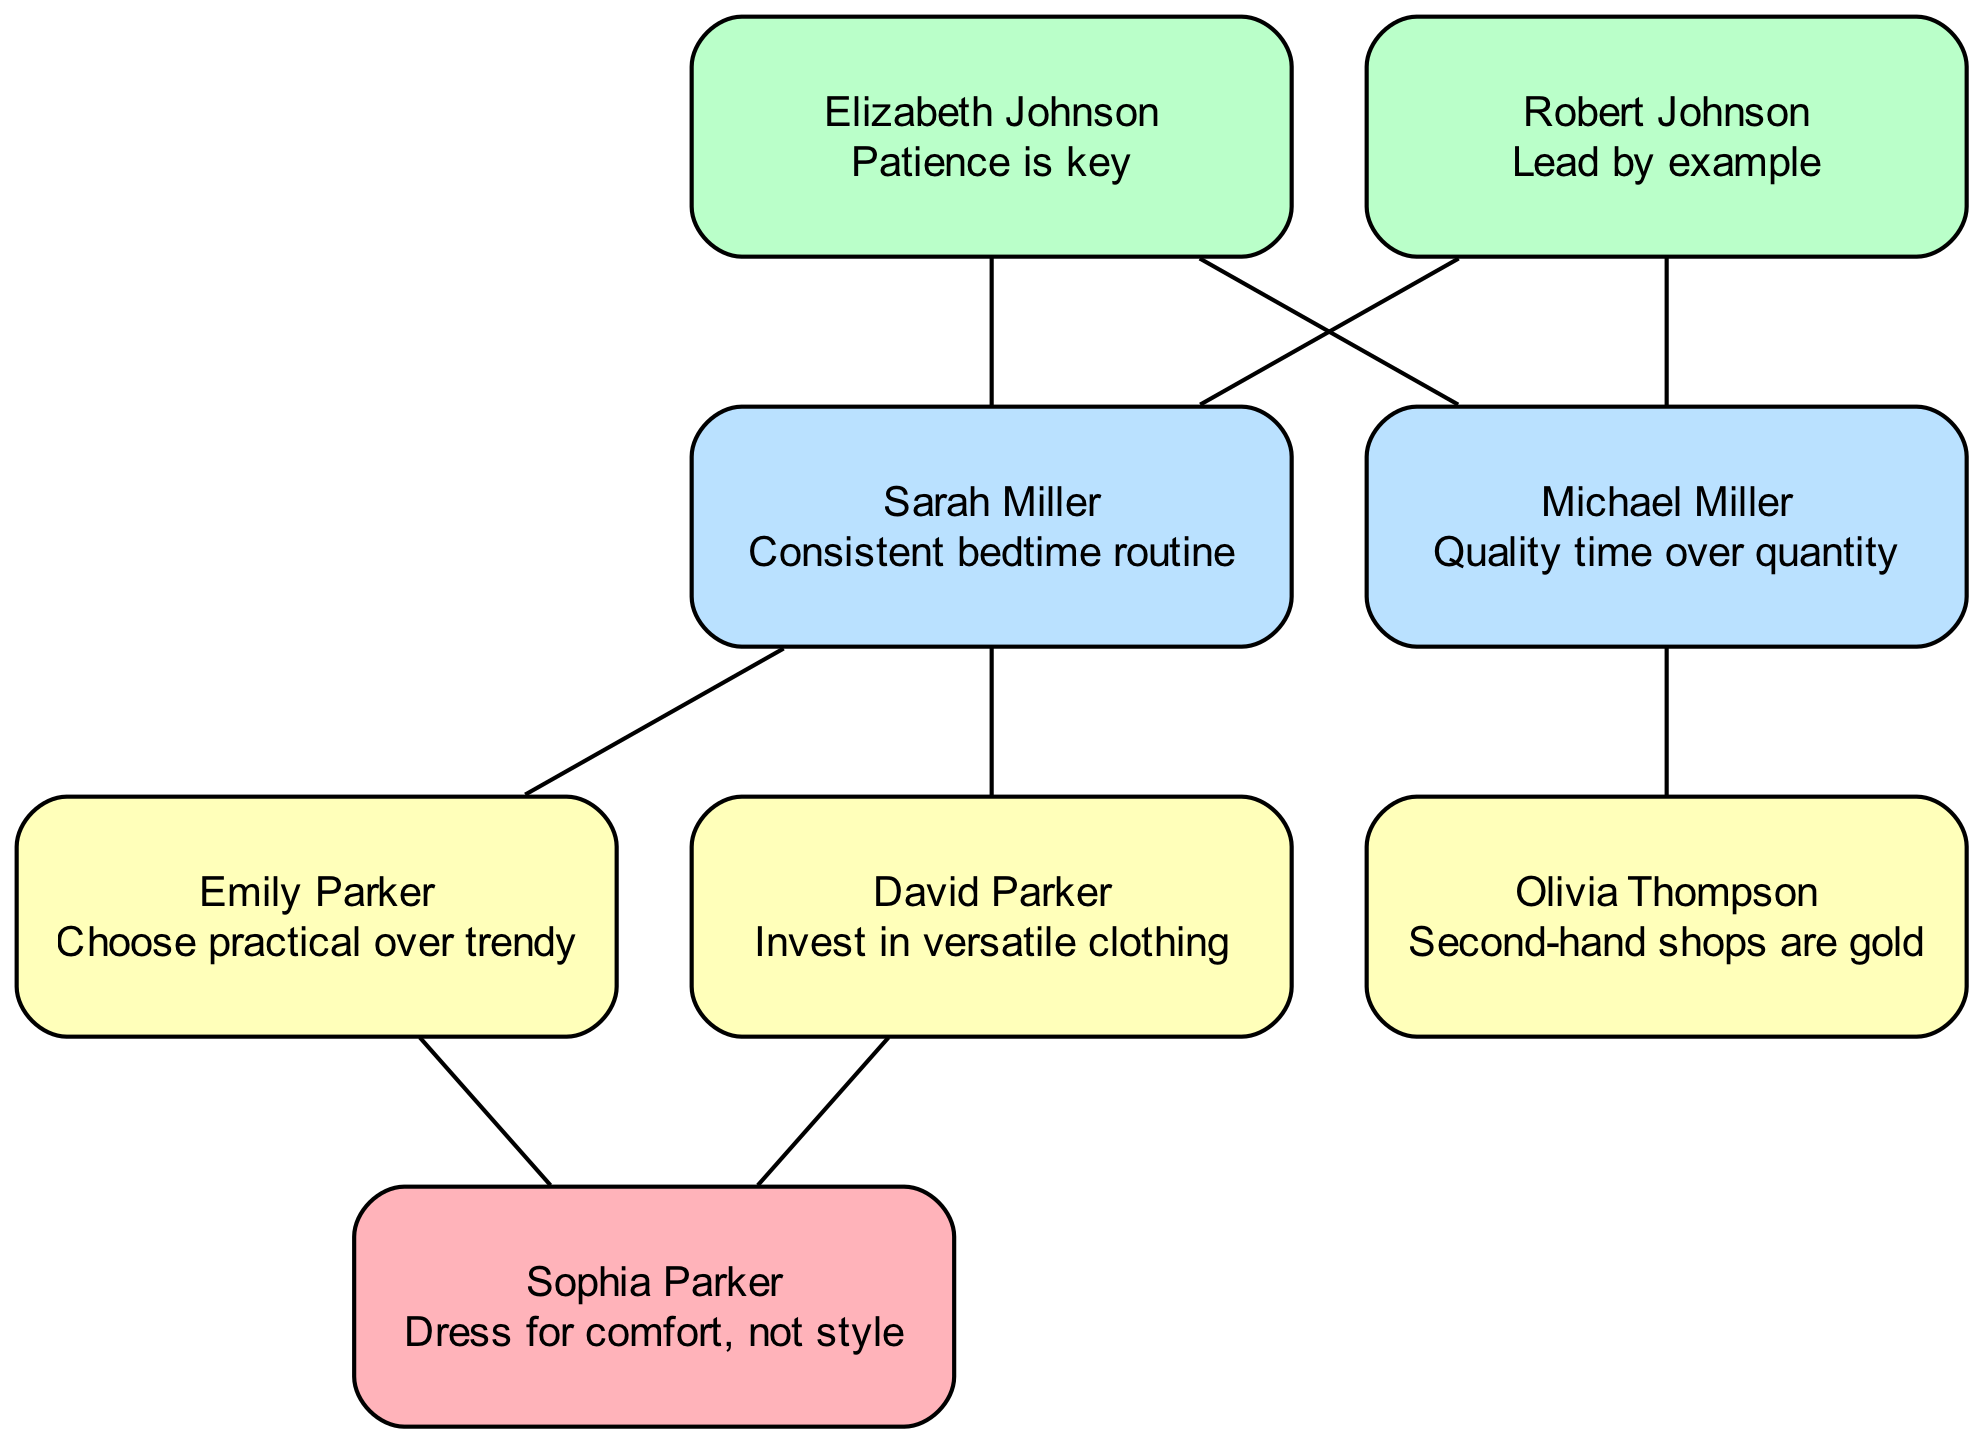What is Elizabeth Johnson's parenting advice? The diagram shows that Elizabeth Johnson's advice is presented directly in her node, with the text "Patience is key" clearly listed.
Answer: Patience is key How many generations are represented in the family tree? By counting the distinct generations in the provided data, we see that the first generation contains Elizabeth and Robert, the second contains Sarah and Michael, the third contains Emily, David, and Olivia, and the fourth has Sophia. This makes for a total of four generations.
Answer: 4 Who is the parent of Emily Parker? The tree indicates that Emily is connected to Sarah Miller, who is listed as her parent. By following the edges in the diagram, we can see this direct relationship.
Answer: Sarah Miller What is the advice given by Michael Miller? The advice specified under Michael Miller's node in the diagram is "Quality time over quantity," which is clearly stated.
Answer: Quality time over quantity Which family member advises to invest in versatile clothing? Looking at the information in the diagram, David Parker's node clearly states that his advice is "Invest in versatile clothing," making it straightforward to identify him as the source of this advice.
Answer: David Parker How many pieces of advice are shared by members in the third generation? We can determine the number of distinct pieces of advice in the third generation by listing them for Emily, David, and Olivia, which totals to three. This involves counting the unique advice provided by each of these three members.
Answer: 3 What is the relationship between Sophia Parker and Emily Parker? The diagram shows that Sophia is a child of Emily Parker, establishing a parent-child relationship. By tracing the edges, one can confirm this direct connection in family lineage.
Answer: Mother Which advice is associated with Olivia Thompson? Inspecting Olivia Thompson's node in the diagram reveals that her advice, written directly there, is "Second-hand shops are gold." This clearly defines her shared wisdom as a parent.
Answer: Second-hand shops are gold 